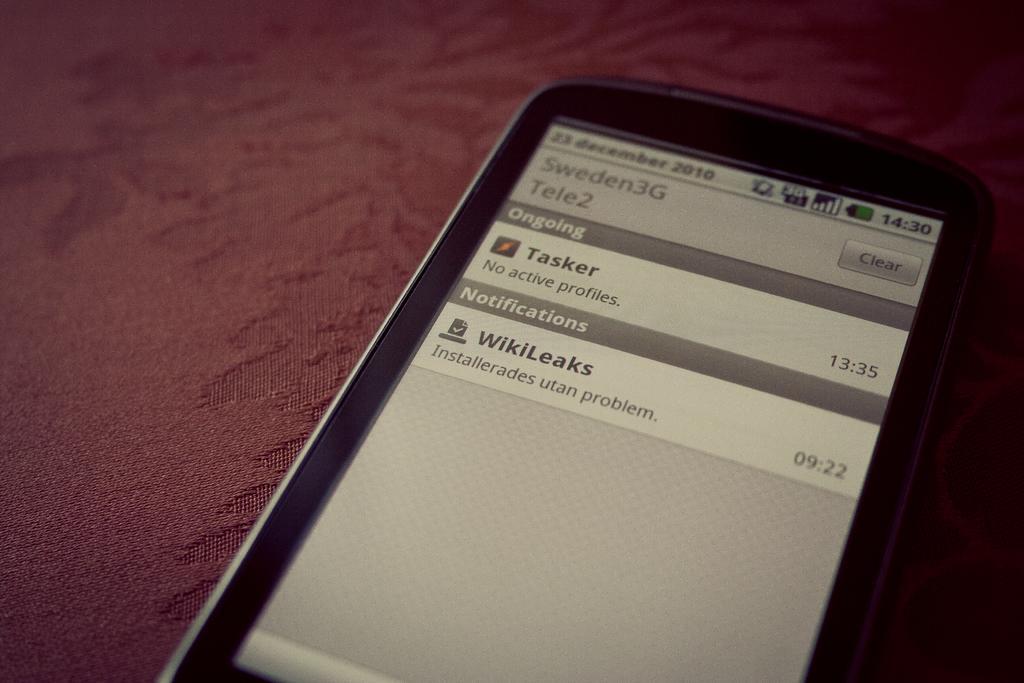Could you give a brief overview of what you see in this image? In this image I can see maroon colour cloth and on it I can see a black colour phone. In its screen I can see few things are written. 